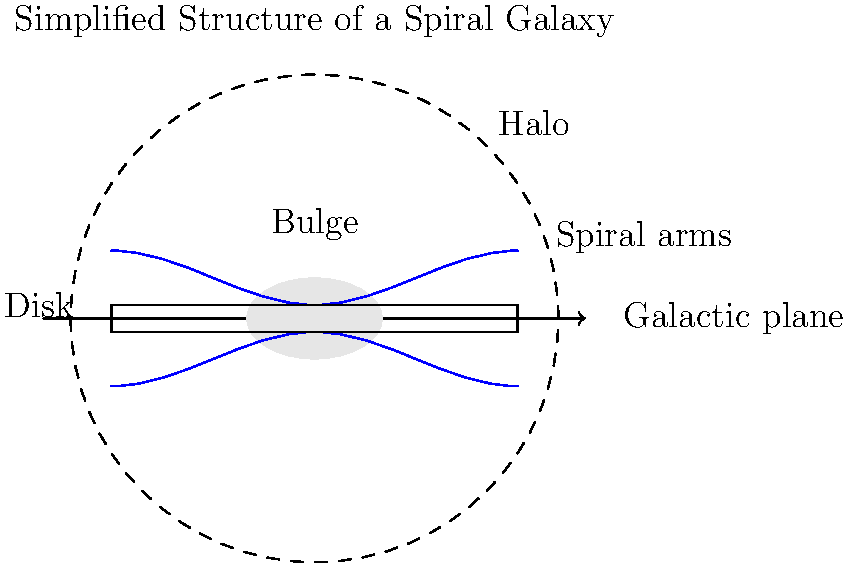In the simplified representation of a spiral galaxy shown above, which component is typically associated with the oldest stars and extends far beyond the visible disk? How might this component's existence be detected through its influence on the galaxy's soundtrack? To answer this question, let's break down the components of a spiral galaxy and their characteristics:

1. Galactic plane: The main plane of the galaxy where most visible matter is concentrated.
2. Bulge: The central, roughly spherical component containing older stars.
3. Disk: The flat, circular region containing the spiral arms and most of the galaxy's gas and dust.
4. Spiral arms: The distinctive spiral-shaped regions of star formation.
5. Halo: The extended, spherical region surrounding the entire galaxy.

The component associated with the oldest stars and extending far beyond the visible disk is the halo. Here's why:

1. Age of stars: The halo contains mostly old, low-mass stars called Population II stars, which formed early in the galaxy's history.
2. Extent: The halo extends much farther than the visible disk, often several times the diameter of the disk.
3. Low density: The halo has a very low density of stars compared to the disk and bulge.

Detecting the halo through its influence on the galaxy's soundtrack:

1. Low-frequency sounds: The old, low-mass stars in the halo would produce lower-frequency sounds in a musical representation of the galaxy.
2. Subtle background: The halo's influence might be heard as a subtle, continuous background sound in the galaxy's soundtrack.
3. Extended duration: Due to the halo's vast size, its sound might persist longer than other components in a time-based representation of the galaxy's structure.
4. Doppler effect: The motion of halo stars might be represented by slight pitch variations in the soundtrack, reflecting their orbital velocities around the galaxy center.

By listening carefully to the galaxy's soundtrack, one might detect these subtle audio cues representing the halo's presence and characteristics.
Answer: Halo 